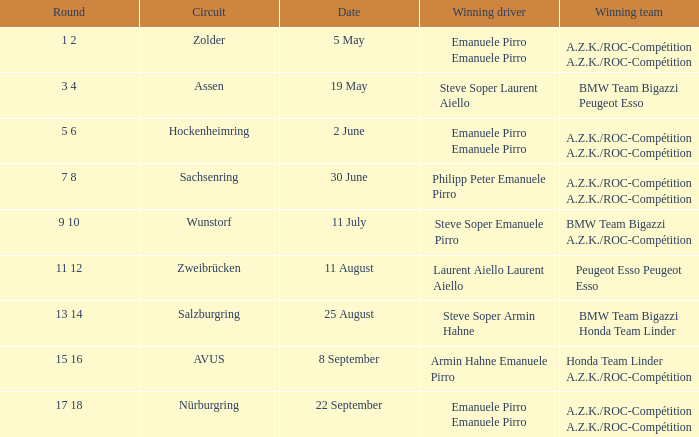What is the date of the zolder circuit, which had a.z.k./roc-compétition a.z.k./roc-compétition as the winning team? 5 May. 